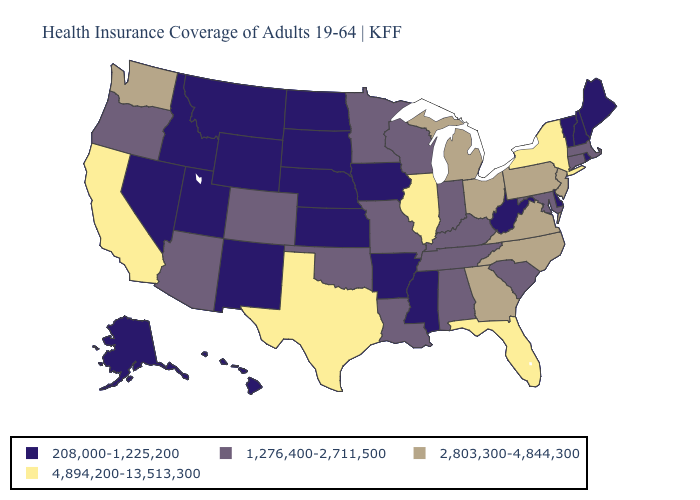Name the states that have a value in the range 4,894,200-13,513,300?
Write a very short answer. California, Florida, Illinois, New York, Texas. Name the states that have a value in the range 208,000-1,225,200?
Be succinct. Alaska, Arkansas, Delaware, Hawaii, Idaho, Iowa, Kansas, Maine, Mississippi, Montana, Nebraska, Nevada, New Hampshire, New Mexico, North Dakota, Rhode Island, South Dakota, Utah, Vermont, West Virginia, Wyoming. Name the states that have a value in the range 1,276,400-2,711,500?
Quick response, please. Alabama, Arizona, Colorado, Connecticut, Indiana, Kentucky, Louisiana, Maryland, Massachusetts, Minnesota, Missouri, Oklahoma, Oregon, South Carolina, Tennessee, Wisconsin. Name the states that have a value in the range 208,000-1,225,200?
Be succinct. Alaska, Arkansas, Delaware, Hawaii, Idaho, Iowa, Kansas, Maine, Mississippi, Montana, Nebraska, Nevada, New Hampshire, New Mexico, North Dakota, Rhode Island, South Dakota, Utah, Vermont, West Virginia, Wyoming. Does the map have missing data?
Give a very brief answer. No. Does Nevada have a lower value than South Carolina?
Quick response, please. Yes. Among the states that border Louisiana , does Texas have the lowest value?
Short answer required. No. What is the highest value in the South ?
Short answer required. 4,894,200-13,513,300. What is the value of South Dakota?
Quick response, please. 208,000-1,225,200. Is the legend a continuous bar?
Give a very brief answer. No. Which states have the highest value in the USA?
Be succinct. California, Florida, Illinois, New York, Texas. Name the states that have a value in the range 1,276,400-2,711,500?
Quick response, please. Alabama, Arizona, Colorado, Connecticut, Indiana, Kentucky, Louisiana, Maryland, Massachusetts, Minnesota, Missouri, Oklahoma, Oregon, South Carolina, Tennessee, Wisconsin. Does Michigan have a lower value than Florida?
Give a very brief answer. Yes. What is the value of Utah?
Give a very brief answer. 208,000-1,225,200. Does the first symbol in the legend represent the smallest category?
Quick response, please. Yes. 